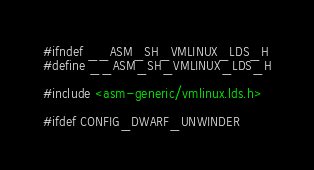Convert code to text. <code><loc_0><loc_0><loc_500><loc_500><_C_>#ifndef __ASM_SH_VMLINUX_LDS_H
#define __ASM_SH_VMLINUX_LDS_H

#include <asm-generic/vmlinux.lds.h>

#ifdef CONFIG_DWARF_UNWINDER</code> 